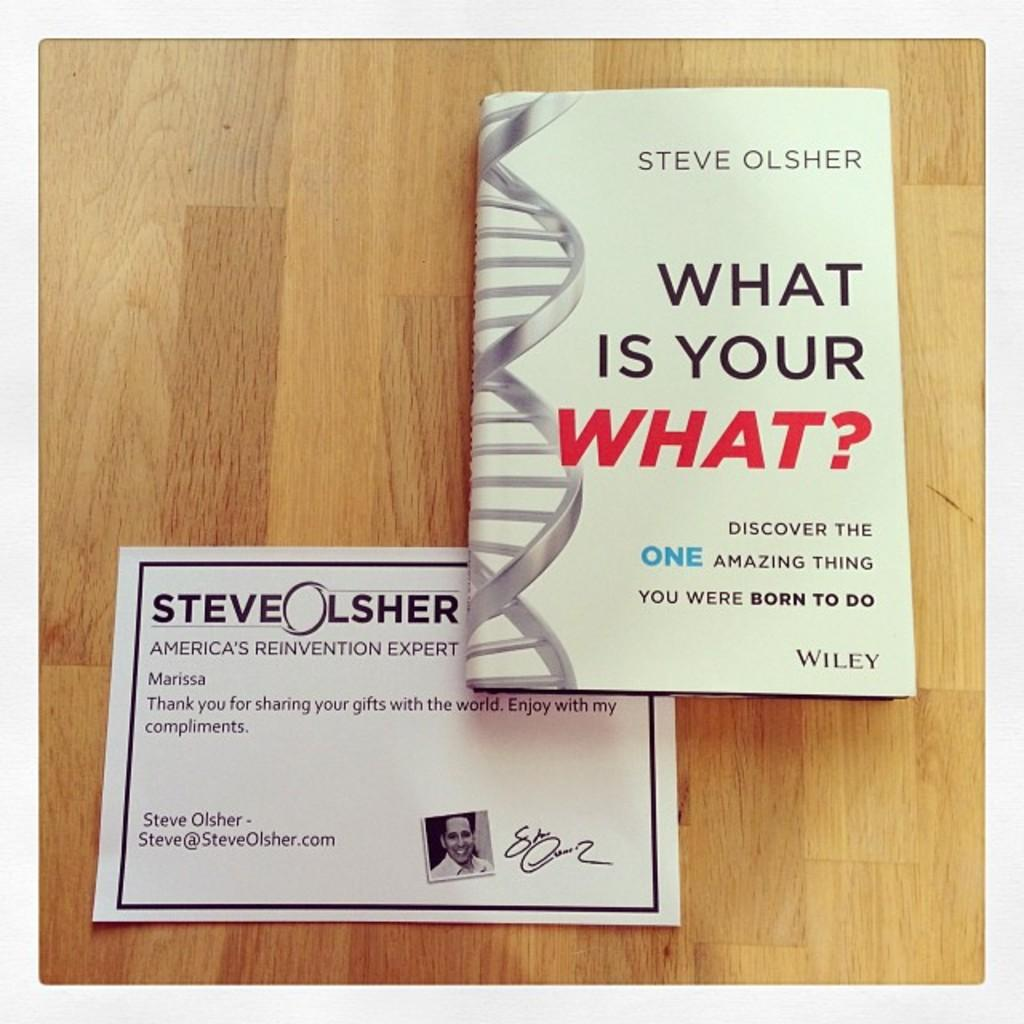Provide a one-sentence caption for the provided image. A book by Steve Olsher is shown with a note below. 